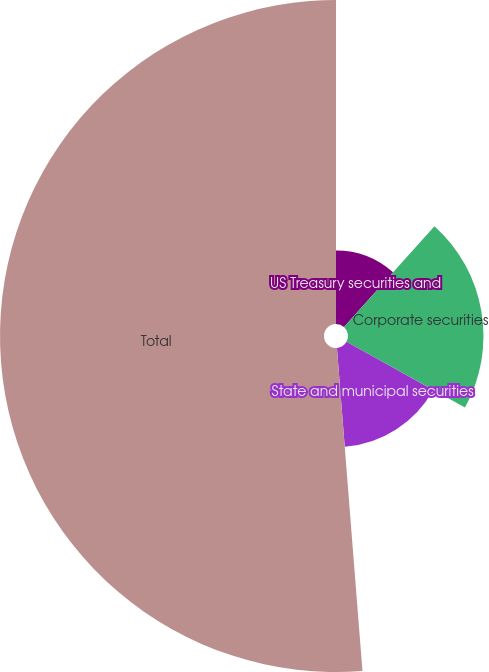Convert chart. <chart><loc_0><loc_0><loc_500><loc_500><pie_chart><fcel>US Treasury securities and<fcel>Corporate securities<fcel>State and municipal securities<fcel>Total<nl><fcel>11.63%<fcel>21.43%<fcel>15.68%<fcel>51.25%<nl></chart> 